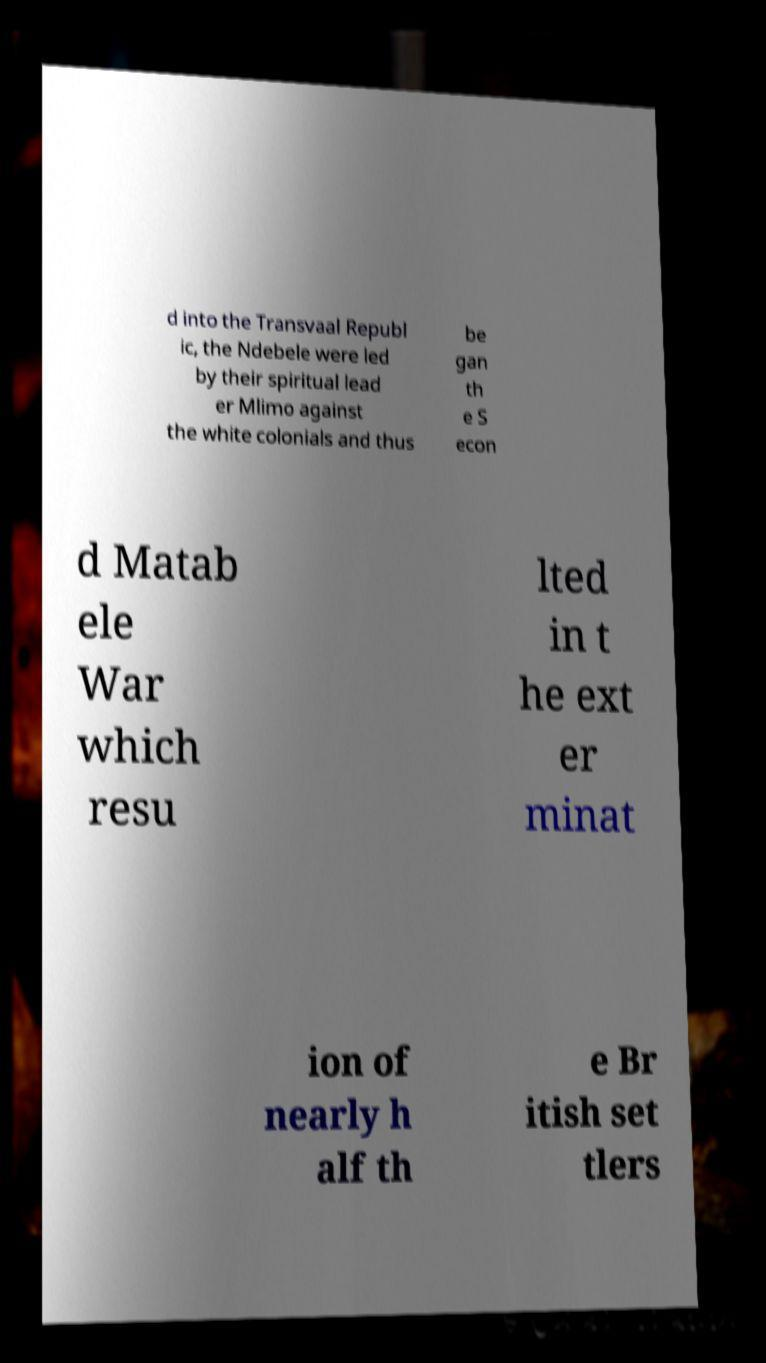What messages or text are displayed in this image? I need them in a readable, typed format. The image shows partial and fragmented text that appears to discuss historical events involving the Ndebele and their conflict with European settlers. It mentions terms like 'Transvaal Republic', 'Ndebele', 'spiritual leader Mlimo', 'white colonials', 'Second Matabele War', and indicates a considerable impact on both Ndebele and British populations. 